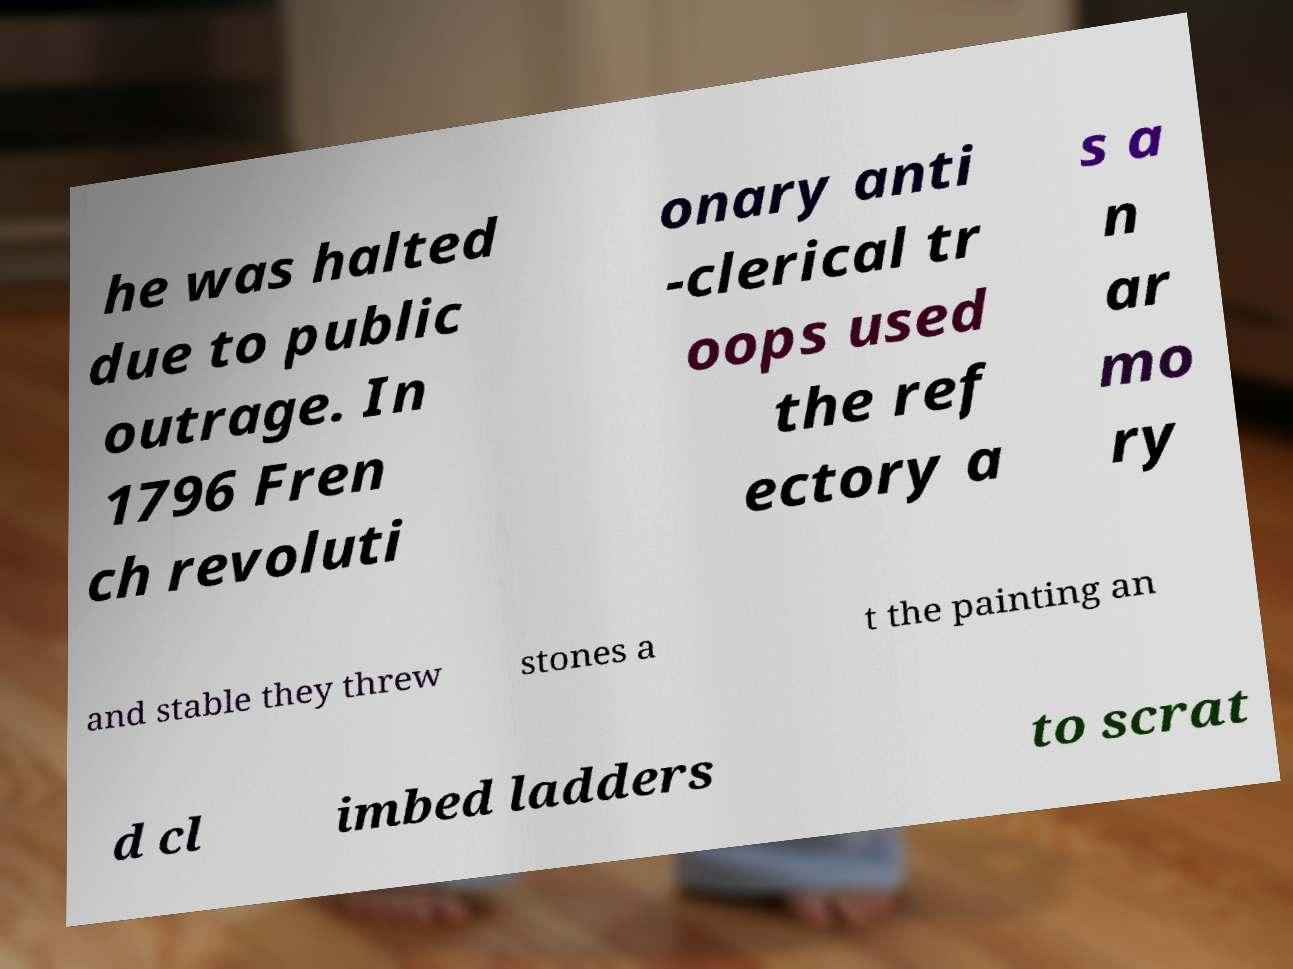Could you extract and type out the text from this image? he was halted due to public outrage. In 1796 Fren ch revoluti onary anti -clerical tr oops used the ref ectory a s a n ar mo ry and stable they threw stones a t the painting an d cl imbed ladders to scrat 